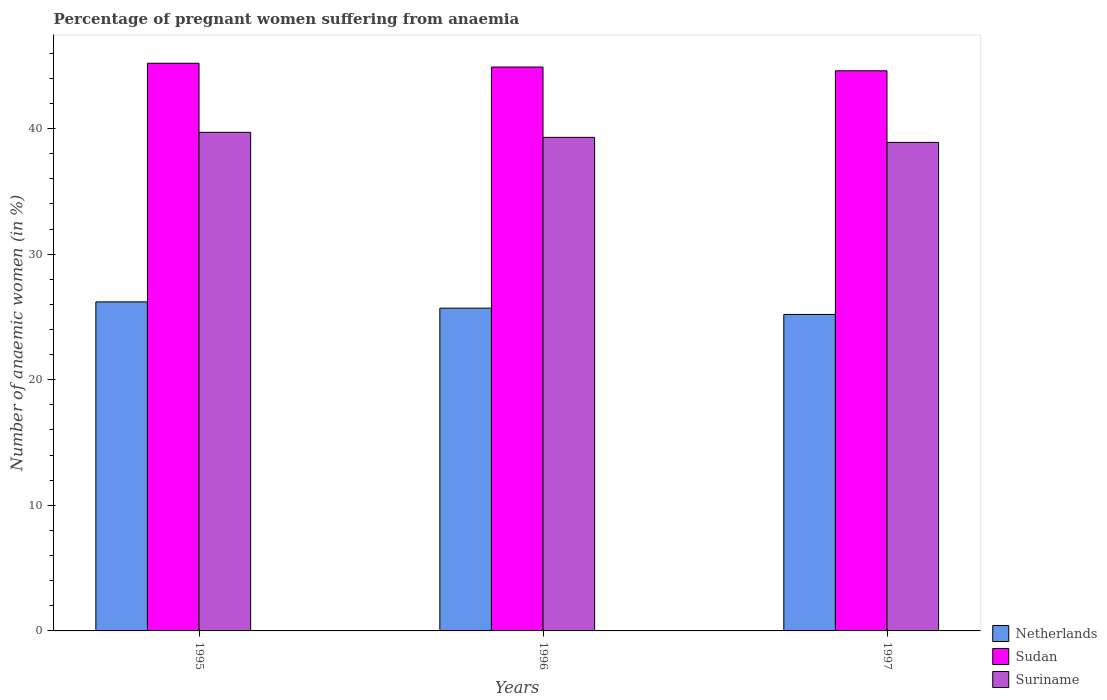How many groups of bars are there?
Provide a succinct answer. 3. Are the number of bars per tick equal to the number of legend labels?
Your answer should be very brief. Yes. Are the number of bars on each tick of the X-axis equal?
Ensure brevity in your answer.  Yes. How many bars are there on the 2nd tick from the left?
Provide a succinct answer. 3. How many bars are there on the 1st tick from the right?
Make the answer very short. 3. What is the label of the 2nd group of bars from the left?
Your answer should be very brief. 1996. In how many cases, is the number of bars for a given year not equal to the number of legend labels?
Provide a succinct answer. 0. What is the number of anaemic women in Netherlands in 1996?
Offer a very short reply. 25.7. Across all years, what is the maximum number of anaemic women in Sudan?
Your answer should be very brief. 45.2. Across all years, what is the minimum number of anaemic women in Netherlands?
Make the answer very short. 25.2. In which year was the number of anaemic women in Suriname maximum?
Your answer should be compact. 1995. What is the total number of anaemic women in Sudan in the graph?
Offer a terse response. 134.7. What is the difference between the number of anaemic women in Sudan in 1996 and that in 1997?
Provide a short and direct response. 0.3. What is the difference between the number of anaemic women in Netherlands in 1997 and the number of anaemic women in Sudan in 1995?
Provide a succinct answer. -20. What is the average number of anaemic women in Sudan per year?
Your answer should be compact. 44.9. In the year 1995, what is the difference between the number of anaemic women in Netherlands and number of anaemic women in Sudan?
Your answer should be very brief. -19. In how many years, is the number of anaemic women in Suriname greater than 36 %?
Provide a succinct answer. 3. What is the ratio of the number of anaemic women in Sudan in 1995 to that in 1997?
Make the answer very short. 1.01. What is the difference between the highest and the second highest number of anaemic women in Netherlands?
Give a very brief answer. 0.5. What is the difference between the highest and the lowest number of anaemic women in Sudan?
Provide a short and direct response. 0.6. In how many years, is the number of anaemic women in Netherlands greater than the average number of anaemic women in Netherlands taken over all years?
Offer a very short reply. 1. What does the 1st bar from the left in 1995 represents?
Ensure brevity in your answer.  Netherlands. What does the 3rd bar from the right in 1996 represents?
Make the answer very short. Netherlands. How many bars are there?
Provide a short and direct response. 9. Does the graph contain grids?
Provide a short and direct response. No. Where does the legend appear in the graph?
Your answer should be compact. Bottom right. How many legend labels are there?
Provide a succinct answer. 3. What is the title of the graph?
Offer a very short reply. Percentage of pregnant women suffering from anaemia. Does "Congo (Democratic)" appear as one of the legend labels in the graph?
Make the answer very short. No. What is the label or title of the X-axis?
Your response must be concise. Years. What is the label or title of the Y-axis?
Offer a terse response. Number of anaemic women (in %). What is the Number of anaemic women (in %) of Netherlands in 1995?
Ensure brevity in your answer.  26.2. What is the Number of anaemic women (in %) of Sudan in 1995?
Keep it short and to the point. 45.2. What is the Number of anaemic women (in %) in Suriname in 1995?
Offer a terse response. 39.7. What is the Number of anaemic women (in %) in Netherlands in 1996?
Give a very brief answer. 25.7. What is the Number of anaemic women (in %) in Sudan in 1996?
Provide a succinct answer. 44.9. What is the Number of anaemic women (in %) in Suriname in 1996?
Your answer should be compact. 39.3. What is the Number of anaemic women (in %) of Netherlands in 1997?
Offer a very short reply. 25.2. What is the Number of anaemic women (in %) in Sudan in 1997?
Your response must be concise. 44.6. What is the Number of anaemic women (in %) of Suriname in 1997?
Give a very brief answer. 38.9. Across all years, what is the maximum Number of anaemic women (in %) in Netherlands?
Ensure brevity in your answer.  26.2. Across all years, what is the maximum Number of anaemic women (in %) of Sudan?
Provide a short and direct response. 45.2. Across all years, what is the maximum Number of anaemic women (in %) of Suriname?
Make the answer very short. 39.7. Across all years, what is the minimum Number of anaemic women (in %) in Netherlands?
Offer a very short reply. 25.2. Across all years, what is the minimum Number of anaemic women (in %) in Sudan?
Give a very brief answer. 44.6. Across all years, what is the minimum Number of anaemic women (in %) of Suriname?
Offer a terse response. 38.9. What is the total Number of anaemic women (in %) of Netherlands in the graph?
Your answer should be very brief. 77.1. What is the total Number of anaemic women (in %) of Sudan in the graph?
Give a very brief answer. 134.7. What is the total Number of anaemic women (in %) in Suriname in the graph?
Your response must be concise. 117.9. What is the difference between the Number of anaemic women (in %) in Suriname in 1995 and that in 1996?
Offer a very short reply. 0.4. What is the difference between the Number of anaemic women (in %) of Sudan in 1996 and that in 1997?
Your answer should be compact. 0.3. What is the difference between the Number of anaemic women (in %) in Netherlands in 1995 and the Number of anaemic women (in %) in Sudan in 1996?
Make the answer very short. -18.7. What is the difference between the Number of anaemic women (in %) in Sudan in 1995 and the Number of anaemic women (in %) in Suriname in 1996?
Make the answer very short. 5.9. What is the difference between the Number of anaemic women (in %) in Netherlands in 1995 and the Number of anaemic women (in %) in Sudan in 1997?
Your answer should be compact. -18.4. What is the difference between the Number of anaemic women (in %) of Netherlands in 1996 and the Number of anaemic women (in %) of Sudan in 1997?
Offer a very short reply. -18.9. What is the difference between the Number of anaemic women (in %) of Sudan in 1996 and the Number of anaemic women (in %) of Suriname in 1997?
Your answer should be very brief. 6. What is the average Number of anaemic women (in %) in Netherlands per year?
Make the answer very short. 25.7. What is the average Number of anaemic women (in %) in Sudan per year?
Keep it short and to the point. 44.9. What is the average Number of anaemic women (in %) in Suriname per year?
Provide a succinct answer. 39.3. In the year 1995, what is the difference between the Number of anaemic women (in %) in Netherlands and Number of anaemic women (in %) in Sudan?
Keep it short and to the point. -19. In the year 1995, what is the difference between the Number of anaemic women (in %) of Netherlands and Number of anaemic women (in %) of Suriname?
Give a very brief answer. -13.5. In the year 1995, what is the difference between the Number of anaemic women (in %) in Sudan and Number of anaemic women (in %) in Suriname?
Offer a terse response. 5.5. In the year 1996, what is the difference between the Number of anaemic women (in %) in Netherlands and Number of anaemic women (in %) in Sudan?
Ensure brevity in your answer.  -19.2. In the year 1996, what is the difference between the Number of anaemic women (in %) of Netherlands and Number of anaemic women (in %) of Suriname?
Make the answer very short. -13.6. In the year 1997, what is the difference between the Number of anaemic women (in %) of Netherlands and Number of anaemic women (in %) of Sudan?
Keep it short and to the point. -19.4. In the year 1997, what is the difference between the Number of anaemic women (in %) in Netherlands and Number of anaemic women (in %) in Suriname?
Your answer should be compact. -13.7. In the year 1997, what is the difference between the Number of anaemic women (in %) of Sudan and Number of anaemic women (in %) of Suriname?
Provide a succinct answer. 5.7. What is the ratio of the Number of anaemic women (in %) in Netherlands in 1995 to that in 1996?
Give a very brief answer. 1.02. What is the ratio of the Number of anaemic women (in %) in Sudan in 1995 to that in 1996?
Your answer should be very brief. 1.01. What is the ratio of the Number of anaemic women (in %) of Suriname in 1995 to that in 1996?
Your response must be concise. 1.01. What is the ratio of the Number of anaemic women (in %) of Netherlands in 1995 to that in 1997?
Make the answer very short. 1.04. What is the ratio of the Number of anaemic women (in %) of Sudan in 1995 to that in 1997?
Make the answer very short. 1.01. What is the ratio of the Number of anaemic women (in %) of Suriname in 1995 to that in 1997?
Your answer should be compact. 1.02. What is the ratio of the Number of anaemic women (in %) in Netherlands in 1996 to that in 1997?
Give a very brief answer. 1.02. What is the ratio of the Number of anaemic women (in %) in Sudan in 1996 to that in 1997?
Offer a very short reply. 1.01. What is the ratio of the Number of anaemic women (in %) in Suriname in 1996 to that in 1997?
Ensure brevity in your answer.  1.01. What is the difference between the highest and the second highest Number of anaemic women (in %) in Netherlands?
Your response must be concise. 0.5. What is the difference between the highest and the second highest Number of anaemic women (in %) in Suriname?
Keep it short and to the point. 0.4. 